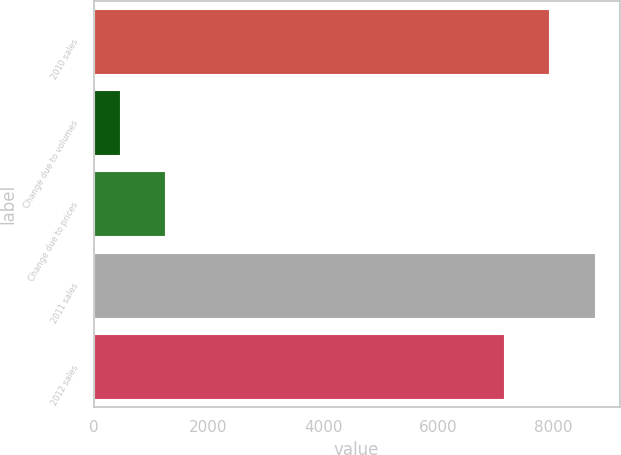Convert chart. <chart><loc_0><loc_0><loc_500><loc_500><bar_chart><fcel>2010 sales<fcel>Change due to volumes<fcel>Change due to prices<fcel>2011 sales<fcel>2012 sales<nl><fcel>7938.7<fcel>458<fcel>1243.7<fcel>8724.4<fcel>7153<nl></chart> 